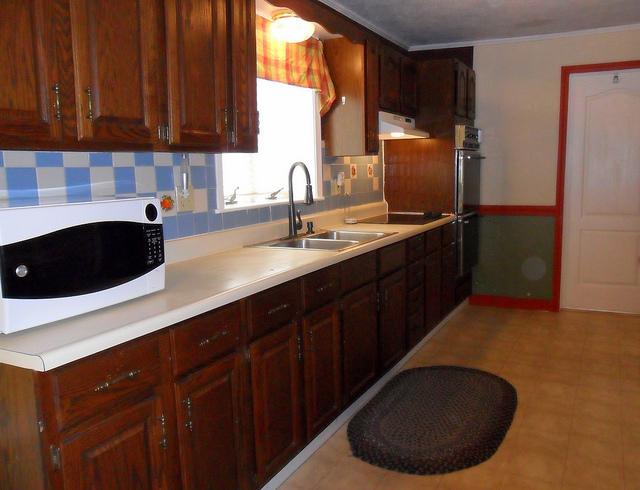Is the a mat on the floor?
Quick response, please. Yes. Is the light on?
Answer briefly. Yes. What color is the microwave on the counter?
Concise answer only. White. 